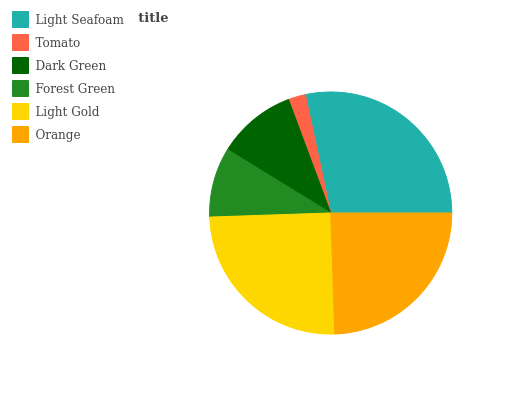Is Tomato the minimum?
Answer yes or no. Yes. Is Light Seafoam the maximum?
Answer yes or no. Yes. Is Dark Green the minimum?
Answer yes or no. No. Is Dark Green the maximum?
Answer yes or no. No. Is Dark Green greater than Tomato?
Answer yes or no. Yes. Is Tomato less than Dark Green?
Answer yes or no. Yes. Is Tomato greater than Dark Green?
Answer yes or no. No. Is Dark Green less than Tomato?
Answer yes or no. No. Is Orange the high median?
Answer yes or no. Yes. Is Dark Green the low median?
Answer yes or no. Yes. Is Light Seafoam the high median?
Answer yes or no. No. Is Light Gold the low median?
Answer yes or no. No. 